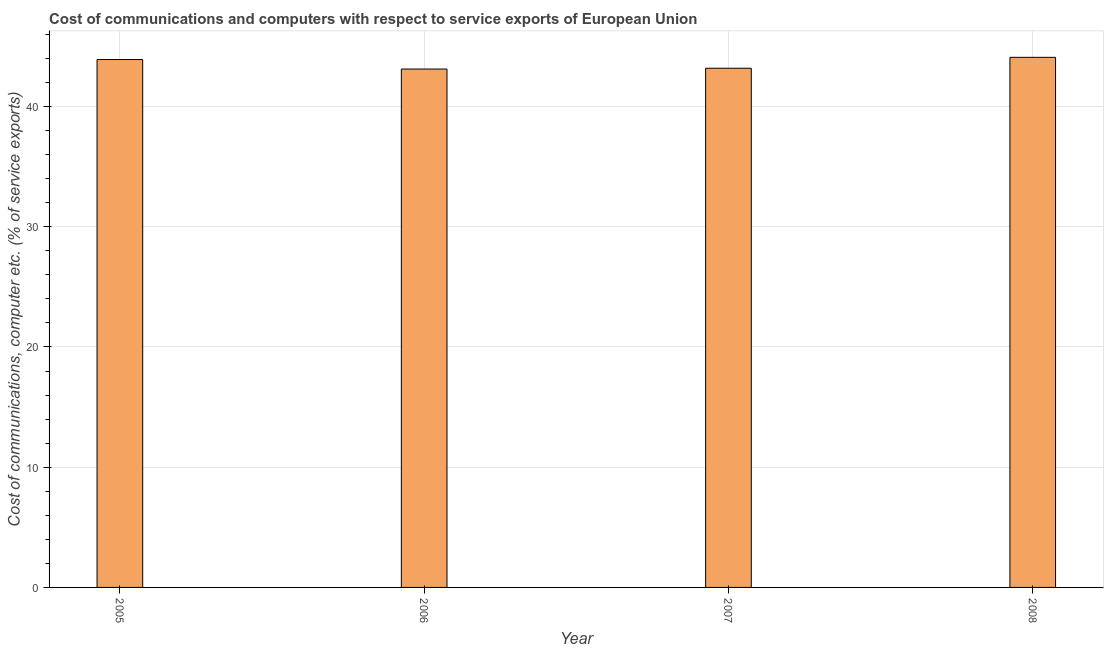Does the graph contain any zero values?
Provide a succinct answer. No. What is the title of the graph?
Your answer should be compact. Cost of communications and computers with respect to service exports of European Union. What is the label or title of the Y-axis?
Offer a very short reply. Cost of communications, computer etc. (% of service exports). What is the cost of communications and computer in 2006?
Keep it short and to the point. 43.12. Across all years, what is the maximum cost of communications and computer?
Make the answer very short. 44.09. Across all years, what is the minimum cost of communications and computer?
Provide a short and direct response. 43.12. In which year was the cost of communications and computer maximum?
Your response must be concise. 2008. In which year was the cost of communications and computer minimum?
Make the answer very short. 2006. What is the sum of the cost of communications and computer?
Keep it short and to the point. 174.31. What is the difference between the cost of communications and computer in 2005 and 2008?
Make the answer very short. -0.18. What is the average cost of communications and computer per year?
Your answer should be compact. 43.58. What is the median cost of communications and computer?
Give a very brief answer. 43.55. Do a majority of the years between 2007 and 2005 (inclusive) have cost of communications and computer greater than 16 %?
Your answer should be compact. Yes. Is the cost of communications and computer in 2007 less than that in 2008?
Keep it short and to the point. Yes. Is the difference between the cost of communications and computer in 2006 and 2008 greater than the difference between any two years?
Provide a short and direct response. Yes. What is the difference between the highest and the second highest cost of communications and computer?
Your answer should be very brief. 0.18. What is the difference between the highest and the lowest cost of communications and computer?
Make the answer very short. 0.97. In how many years, is the cost of communications and computer greater than the average cost of communications and computer taken over all years?
Ensure brevity in your answer.  2. How many bars are there?
Give a very brief answer. 4. Are all the bars in the graph horizontal?
Provide a short and direct response. No. What is the difference between two consecutive major ticks on the Y-axis?
Your answer should be compact. 10. What is the Cost of communications, computer etc. (% of service exports) in 2005?
Ensure brevity in your answer.  43.91. What is the Cost of communications, computer etc. (% of service exports) in 2006?
Make the answer very short. 43.12. What is the Cost of communications, computer etc. (% of service exports) of 2007?
Provide a short and direct response. 43.19. What is the Cost of communications, computer etc. (% of service exports) of 2008?
Offer a very short reply. 44.09. What is the difference between the Cost of communications, computer etc. (% of service exports) in 2005 and 2006?
Ensure brevity in your answer.  0.79. What is the difference between the Cost of communications, computer etc. (% of service exports) in 2005 and 2007?
Provide a short and direct response. 0.72. What is the difference between the Cost of communications, computer etc. (% of service exports) in 2005 and 2008?
Keep it short and to the point. -0.18. What is the difference between the Cost of communications, computer etc. (% of service exports) in 2006 and 2007?
Your response must be concise. -0.07. What is the difference between the Cost of communications, computer etc. (% of service exports) in 2006 and 2008?
Give a very brief answer. -0.97. What is the difference between the Cost of communications, computer etc. (% of service exports) in 2007 and 2008?
Your response must be concise. -0.91. What is the ratio of the Cost of communications, computer etc. (% of service exports) in 2005 to that in 2006?
Keep it short and to the point. 1.02. What is the ratio of the Cost of communications, computer etc. (% of service exports) in 2005 to that in 2007?
Your response must be concise. 1.02. What is the ratio of the Cost of communications, computer etc. (% of service exports) in 2005 to that in 2008?
Ensure brevity in your answer.  1. 